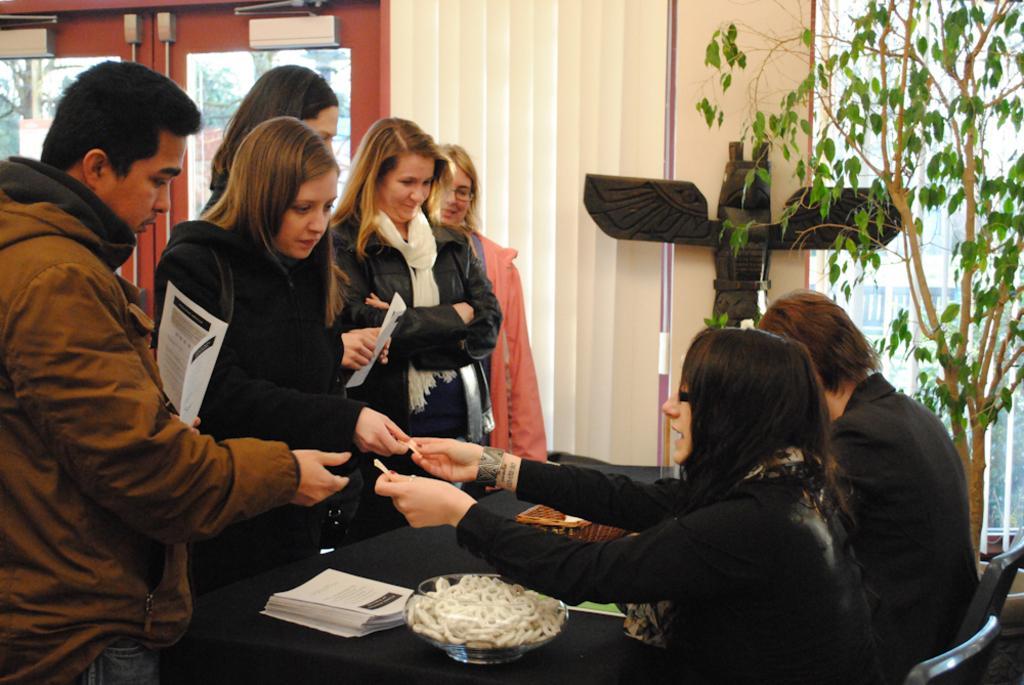In one or two sentences, can you explain what this image depicts? In this picture I can see few people standing and couple of them are holding papers in their hands and I can see couple of them seated on the chairs and I can see papers and basket and a bowl with some items on the table and I can see blinds and a plant and I can see a glass door from the glass I can see building and trees. 